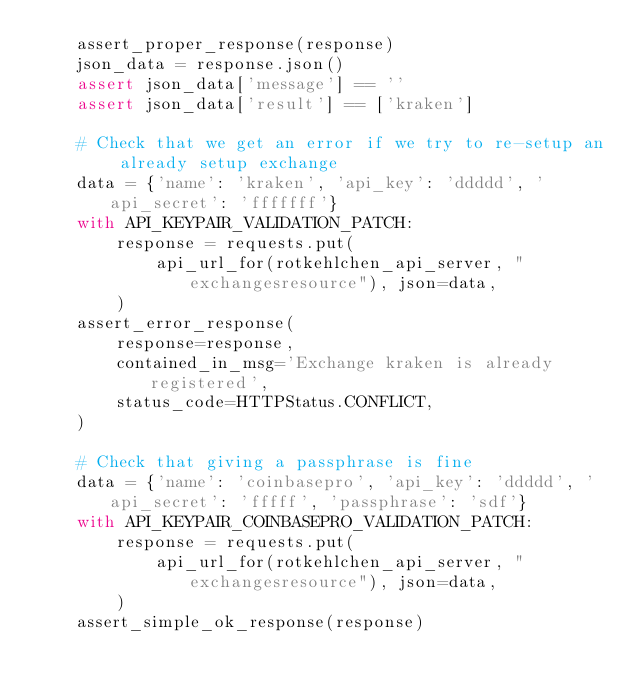Convert code to text. <code><loc_0><loc_0><loc_500><loc_500><_Python_>    assert_proper_response(response)
    json_data = response.json()
    assert json_data['message'] == ''
    assert json_data['result'] == ['kraken']

    # Check that we get an error if we try to re-setup an already setup exchange
    data = {'name': 'kraken', 'api_key': 'ddddd', 'api_secret': 'fffffff'}
    with API_KEYPAIR_VALIDATION_PATCH:
        response = requests.put(
            api_url_for(rotkehlchen_api_server, "exchangesresource"), json=data,
        )
    assert_error_response(
        response=response,
        contained_in_msg='Exchange kraken is already registered',
        status_code=HTTPStatus.CONFLICT,
    )

    # Check that giving a passphrase is fine
    data = {'name': 'coinbasepro', 'api_key': 'ddddd', 'api_secret': 'fffff', 'passphrase': 'sdf'}
    with API_KEYPAIR_COINBASEPRO_VALIDATION_PATCH:
        response = requests.put(
            api_url_for(rotkehlchen_api_server, "exchangesresource"), json=data,
        )
    assert_simple_ok_response(response)</code> 